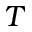Convert formula to latex. <formula><loc_0><loc_0><loc_500><loc_500>T</formula> 